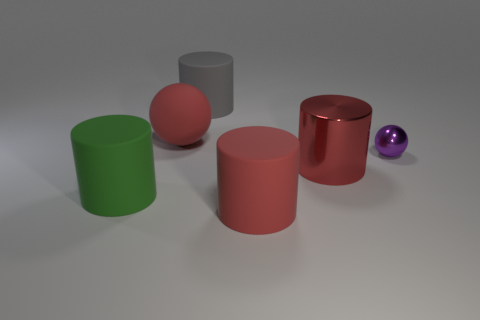What color is the large rubber object that is in front of the matte sphere and to the left of the gray matte thing?
Offer a very short reply. Green. What is the material of the green cylinder that is the same size as the gray cylinder?
Give a very brief answer. Rubber. What color is the other thing that is the same material as the purple thing?
Offer a very short reply. Red. Is the size of the red cylinder that is on the right side of the red matte cylinder the same as the big matte ball?
Make the answer very short. Yes. What color is the metallic object that is the same shape as the big green matte object?
Provide a succinct answer. Red. There is a big thing that is on the right side of the rubber thing on the right side of the large cylinder behind the small metallic sphere; what is its shape?
Your answer should be compact. Cylinder. Do the purple metallic object and the red metallic object have the same shape?
Give a very brief answer. No. There is a big gray object that is left of the ball right of the rubber ball; what shape is it?
Your answer should be very brief. Cylinder. Are there any tiny balls?
Your response must be concise. Yes. There is a red matte object behind the cylinder left of the big red ball; how many big cylinders are on the left side of it?
Your answer should be very brief. 1. 